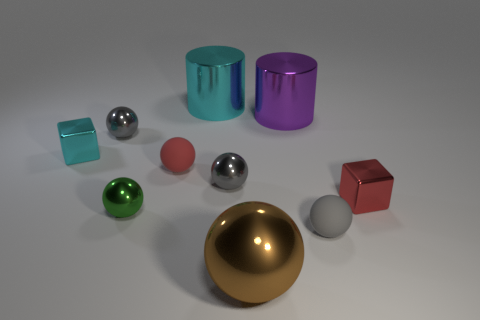Subtract all cyan cubes. How many gray balls are left? 3 Subtract all big metallic balls. How many balls are left? 5 Subtract all red balls. How many balls are left? 5 Subtract all green balls. Subtract all green cylinders. How many balls are left? 5 Subtract all cubes. How many objects are left? 8 Subtract all large spheres. Subtract all big cyan things. How many objects are left? 8 Add 8 red rubber balls. How many red rubber balls are left? 9 Add 1 big red rubber spheres. How many big red rubber spheres exist? 1 Subtract 1 purple cylinders. How many objects are left? 9 